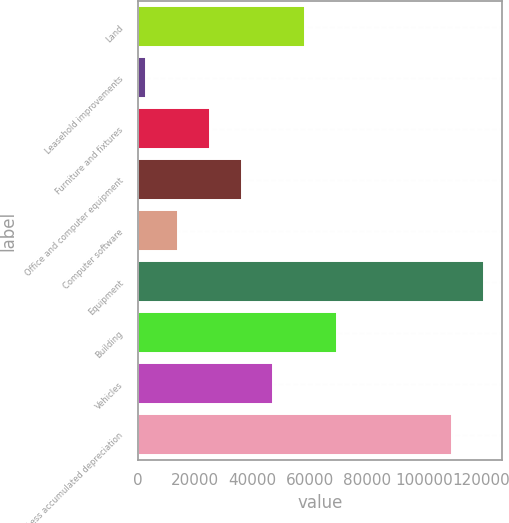Convert chart. <chart><loc_0><loc_0><loc_500><loc_500><bar_chart><fcel>Land<fcel>Leasehold improvements<fcel>Furniture and fixtures<fcel>Office and computer equipment<fcel>Computer software<fcel>Equipment<fcel>Building<fcel>Vehicles<fcel>Less accumulated depreciation<nl><fcel>58458.5<fcel>2687<fcel>24995.6<fcel>36149.9<fcel>13841.3<fcel>121063<fcel>69612.8<fcel>47304.2<fcel>109909<nl></chart> 